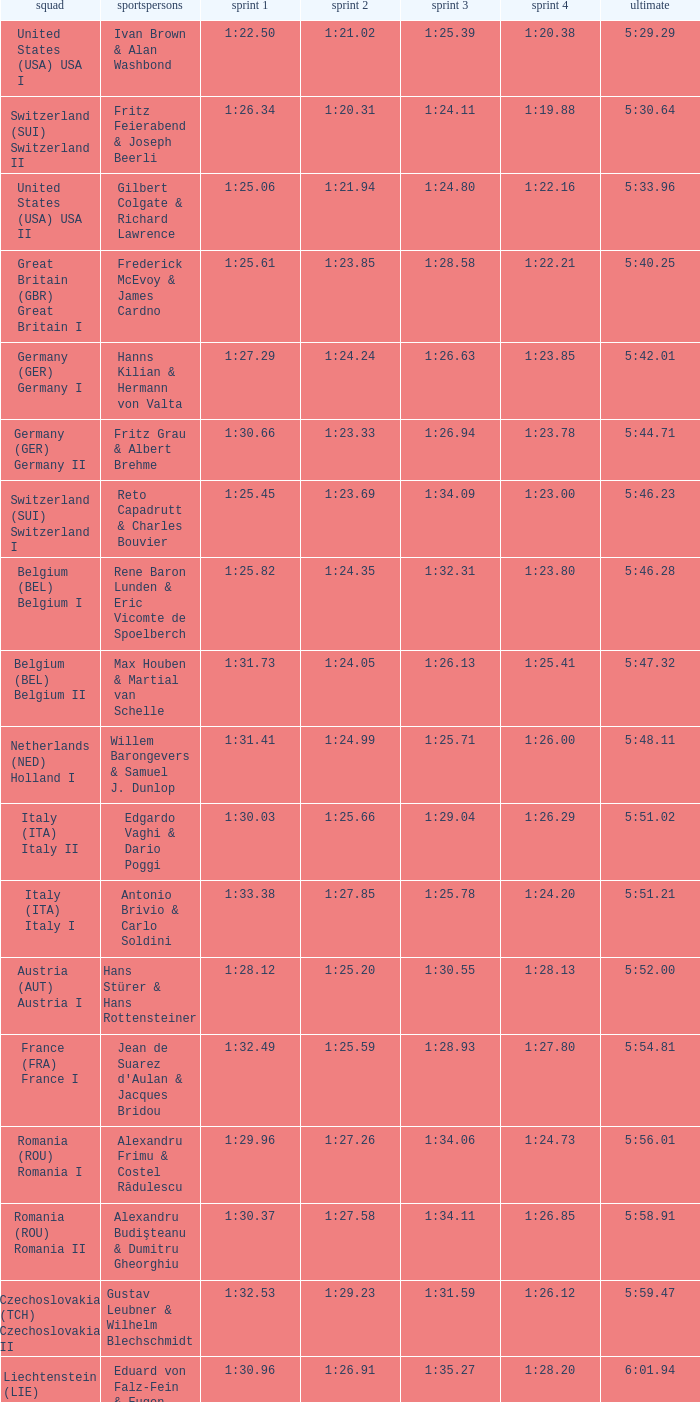Which Run 4 has a Run 1 of 1:25.82? 1:23.80. 